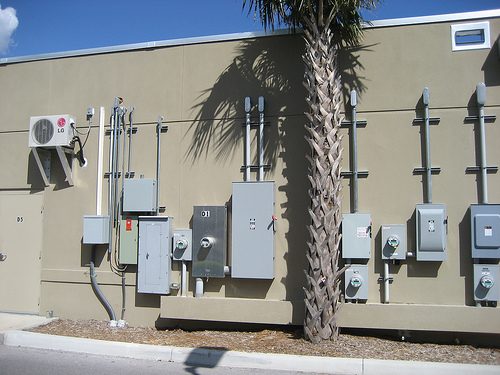<image>
Is there a building behind the tree? Yes. From this viewpoint, the building is positioned behind the tree, with the tree partially or fully occluding the building. Is the palm tree above the building? Yes. The palm tree is positioned above the building in the vertical space, higher up in the scene. 